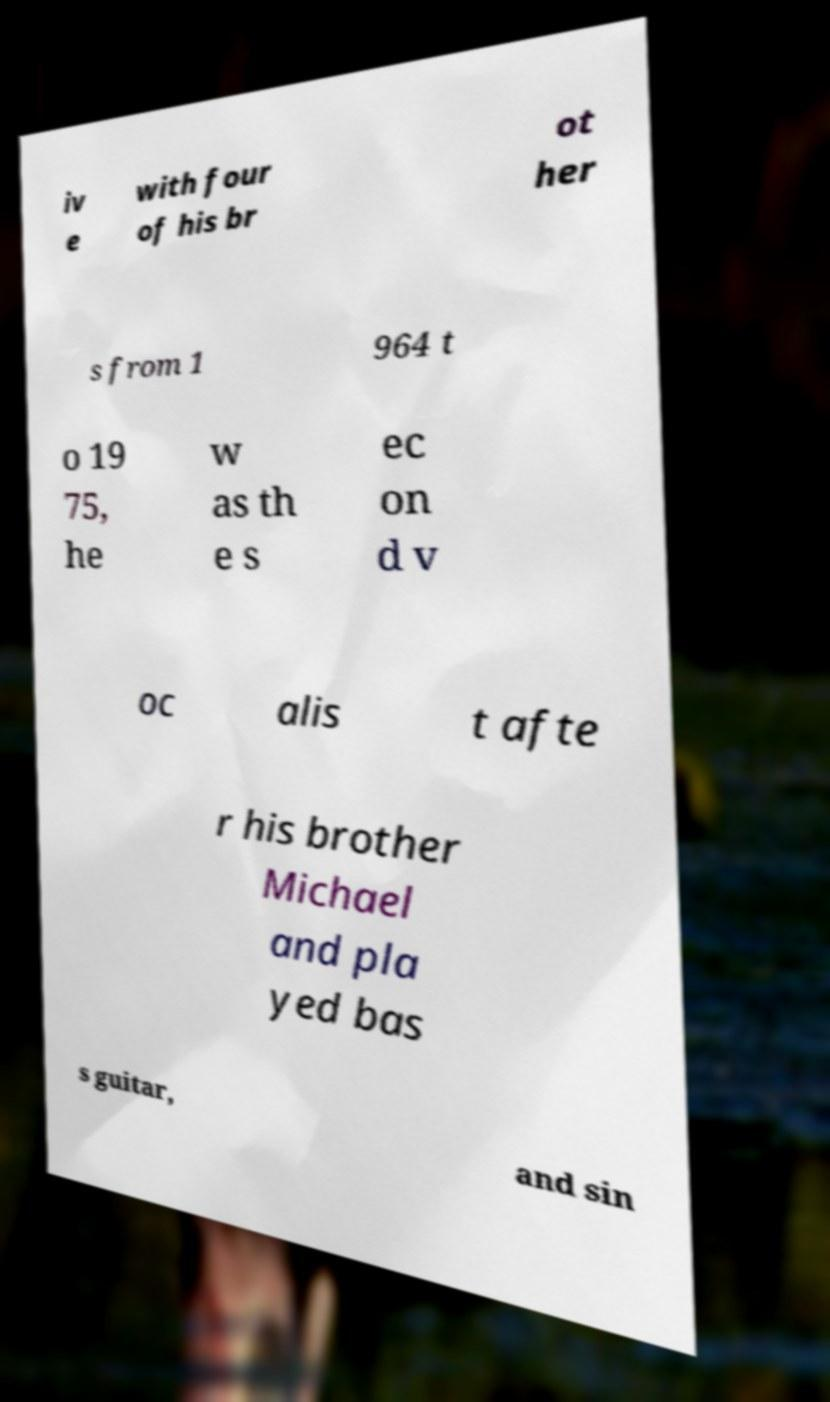Can you accurately transcribe the text from the provided image for me? iv e with four of his br ot her s from 1 964 t o 19 75, he w as th e s ec on d v oc alis t afte r his brother Michael and pla yed bas s guitar, and sin 